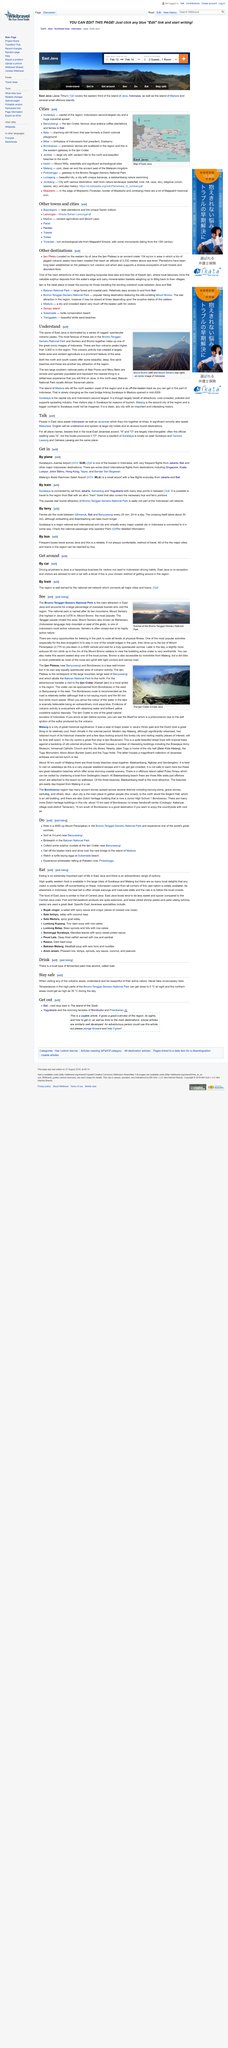Indicate a few pertinent items in this graphic. The photo depicts two volcanic peaks, Mount Bromo and Mount Semeru, which are visible in the image. East Java is located in Indonesia. Madura, a remote island located off the north eastern coast of Indonesia, is the answer to the question. 